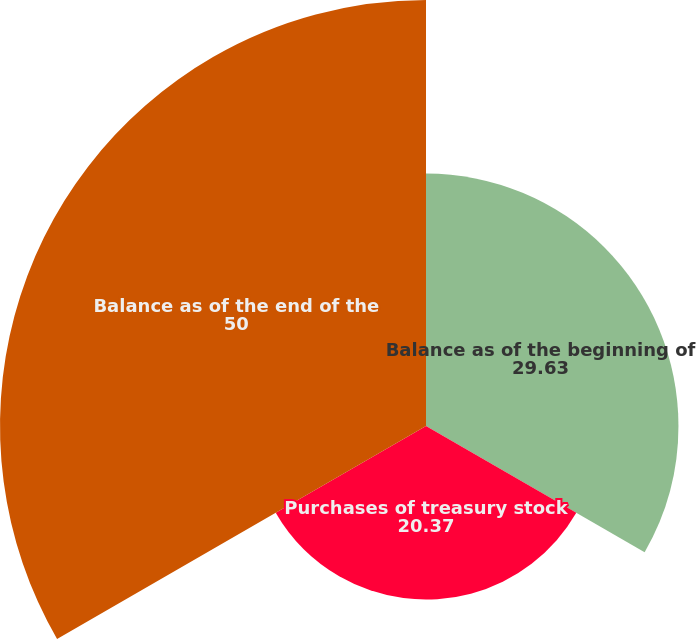Convert chart. <chart><loc_0><loc_0><loc_500><loc_500><pie_chart><fcel>Balance as of the beginning of<fcel>Purchases of treasury stock<fcel>Balance as of the end of the<nl><fcel>29.63%<fcel>20.37%<fcel>50.0%<nl></chart> 